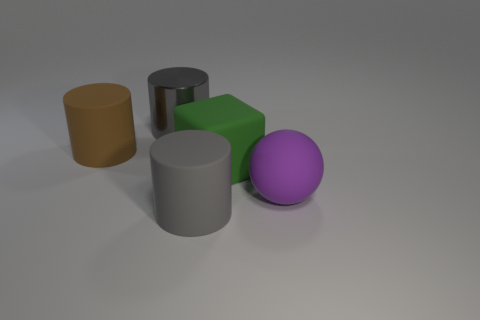There is a gray shiny thing that is the same shape as the brown object; what size is it?
Offer a terse response. Large. There is a large cylinder that is in front of the big gray metal object and behind the large purple ball; what color is it?
Offer a very short reply. Brown. Do the green object and the gray cylinder that is in front of the block have the same material?
Keep it short and to the point. Yes. Is the number of objects to the left of the metal cylinder less than the number of big shiny cylinders?
Make the answer very short. No. What number of other objects are the same shape as the brown thing?
Your answer should be very brief. 2. Are there any other things that have the same color as the big matte ball?
Provide a short and direct response. No. Does the cube have the same color as the big cylinder that is behind the brown cylinder?
Ensure brevity in your answer.  No. What number of other objects are there of the same size as the ball?
Offer a very short reply. 4. There is another thing that is the same color as the shiny object; what size is it?
Keep it short and to the point. Large. What number of cylinders are large green rubber things or big objects?
Provide a short and direct response. 3. 